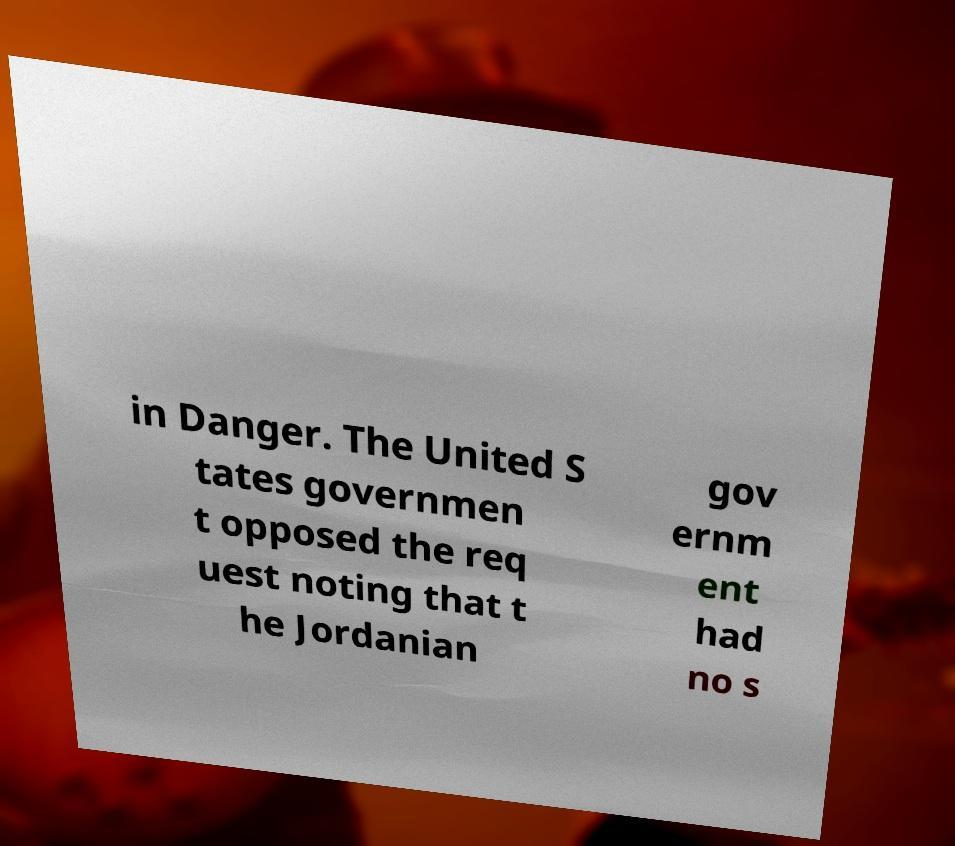Can you read and provide the text displayed in the image?This photo seems to have some interesting text. Can you extract and type it out for me? in Danger. The United S tates governmen t opposed the req uest noting that t he Jordanian gov ernm ent had no s 